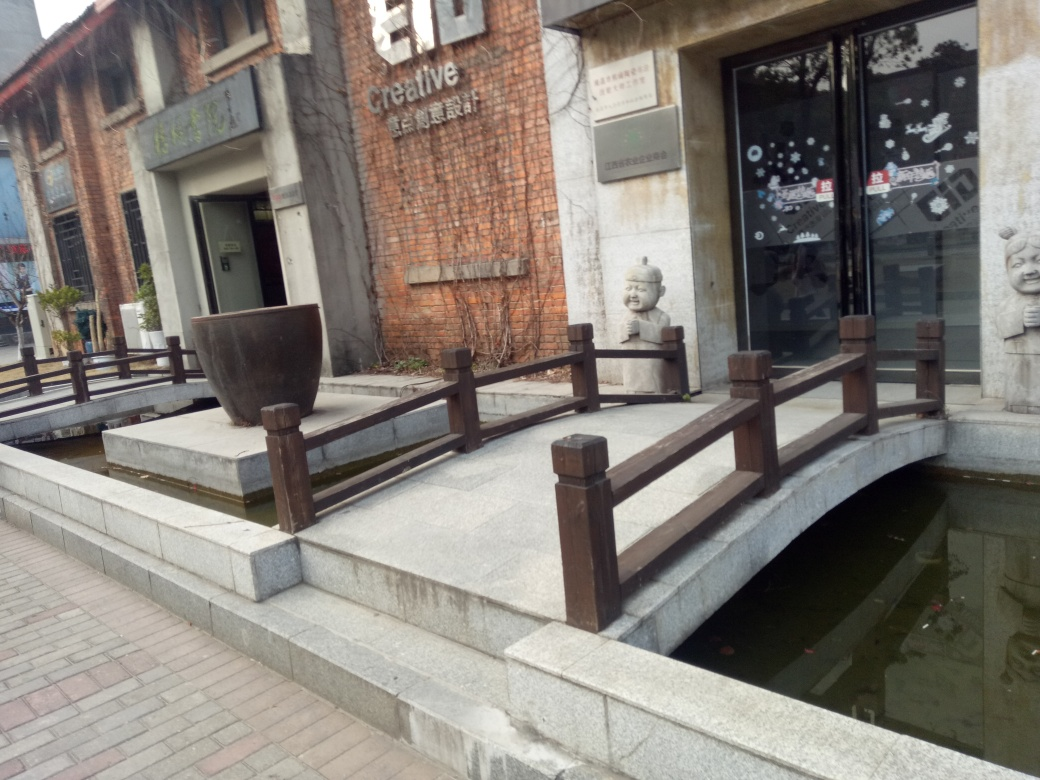Are there any prominent elements in the frame?
A. A lot
B. Some
C. Yes
D. No There are indeed some striking elements in the image. Several standout features include a large, spherical pot at the forefront on top of a pedestal, a footbridge with traditional wooden handrails over a reflective water body, posters or artwork on the doors of a building with a brick facade, and what appear to be artistic sculptural elements resembling human faces adjacent to the glass doors. Therefore, a more appropriate response would have been option B, Some. 